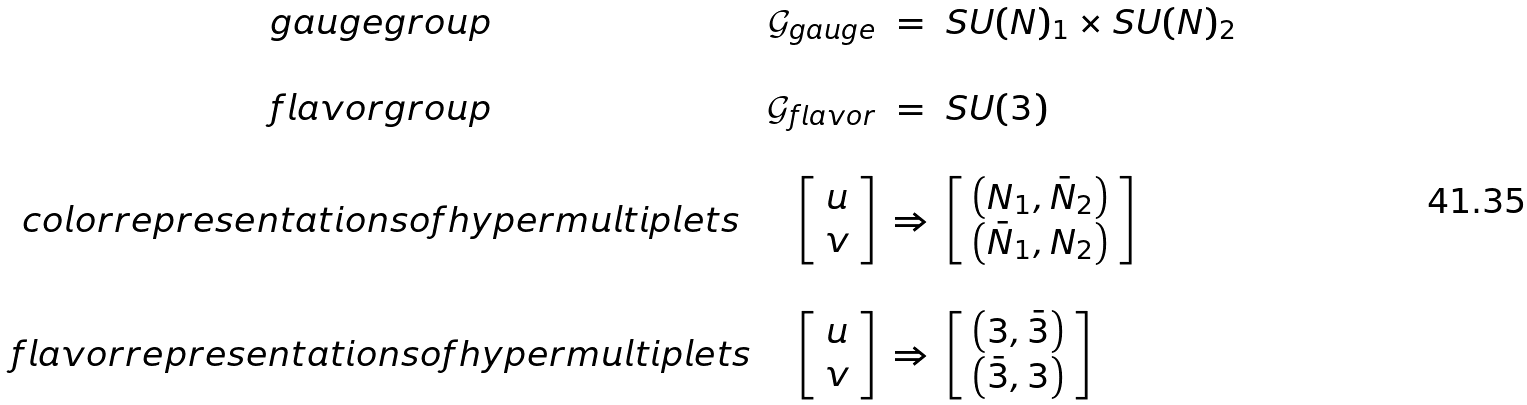<formula> <loc_0><loc_0><loc_500><loc_500>\begin{array} { c r c l } g a u g e g r o u p & \mathcal { G } _ { g a u g e } & = & S U ( N ) _ { 1 } \times S U ( N ) _ { 2 } \\ \null & \null & \null & \null \\ f l a v o r g r o u p & \mathcal { G } _ { f l a v o r } & = & S U ( 3 ) \\ \null & \null & \null & \null \\ c o l o r r e p r e s e n t a t i o n s o f h y p e r m u l t i p l e t s & \left [ \begin{array} { c } u \\ v \end{array} \right ] & \Rightarrow & \left [ \begin{array} { c } \left ( { N } _ { 1 } , { \bar { N } } _ { 2 } \right ) \\ \left ( { \bar { N } } _ { 1 } , { N } _ { 2 } \right ) \end{array} \right ] \\ \null & \null & \null & \null \\ f l a v o r r e p r e s e n t a t i o n s o f h y p e r m u l t i p l e t s & \left [ \begin{array} { c } u \\ v \end{array} \right ] & \Rightarrow & \left [ \begin{array} { c } \left ( { 3 } , { \bar { 3 } } \right ) \\ \left ( { \bar { 3 } } , { 3 } \right ) \end{array} \right ] \\ \end{array}</formula> 